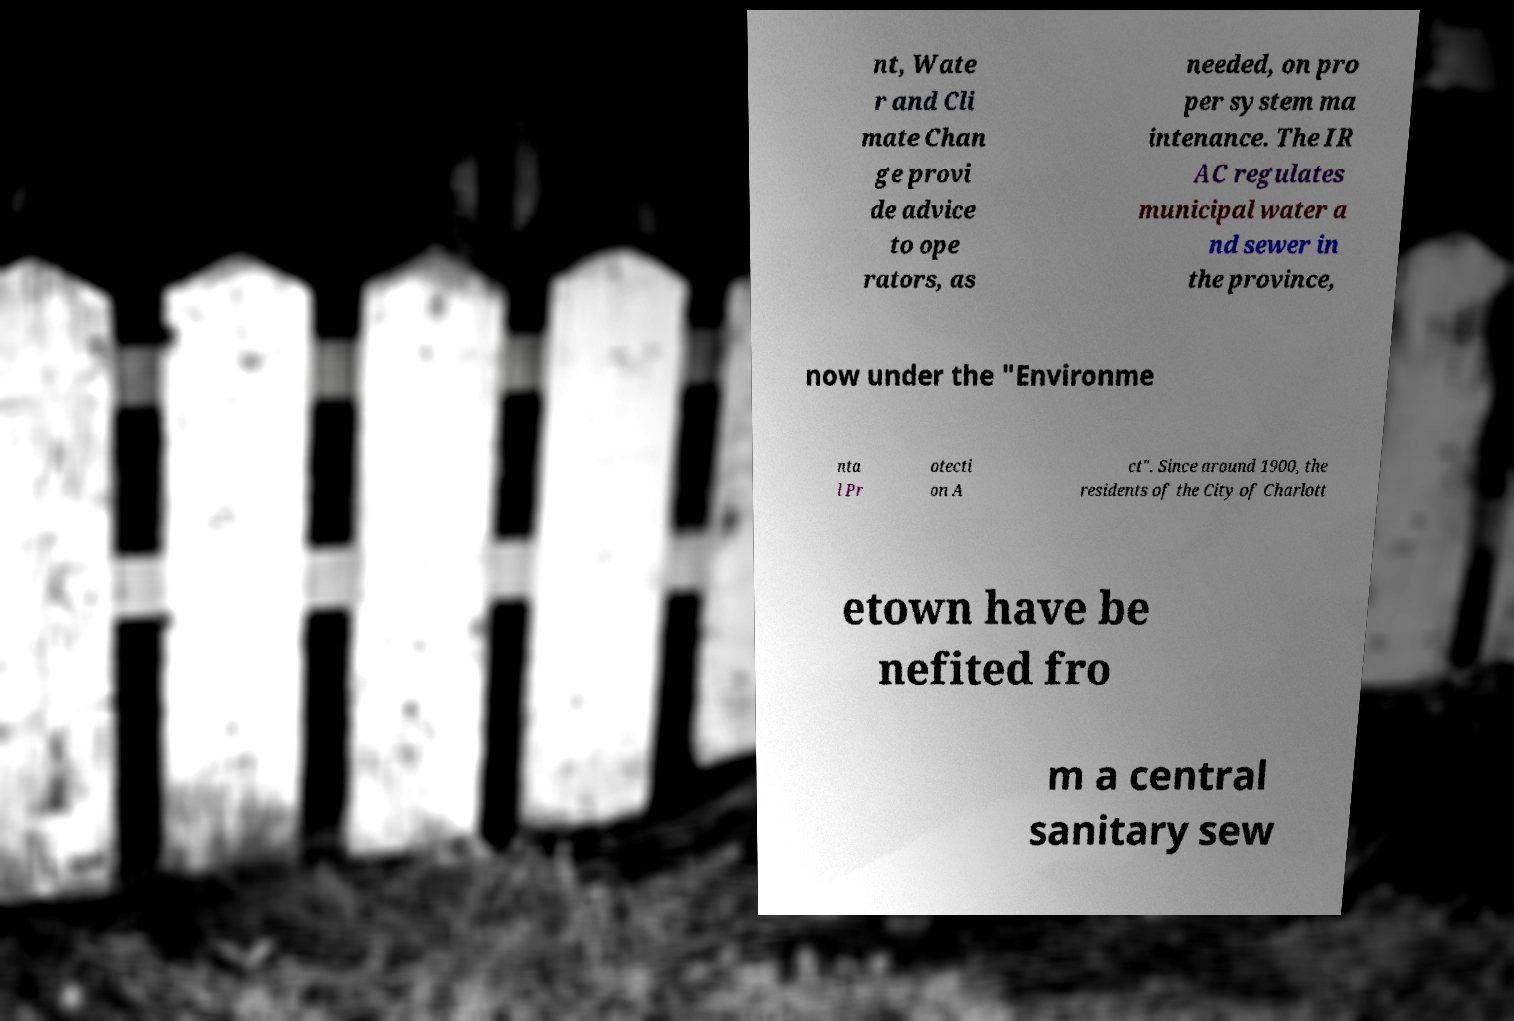There's text embedded in this image that I need extracted. Can you transcribe it verbatim? nt, Wate r and Cli mate Chan ge provi de advice to ope rators, as needed, on pro per system ma intenance. The IR AC regulates municipal water a nd sewer in the province, now under the "Environme nta l Pr otecti on A ct". Since around 1900, the residents of the City of Charlott etown have be nefited fro m a central sanitary sew 